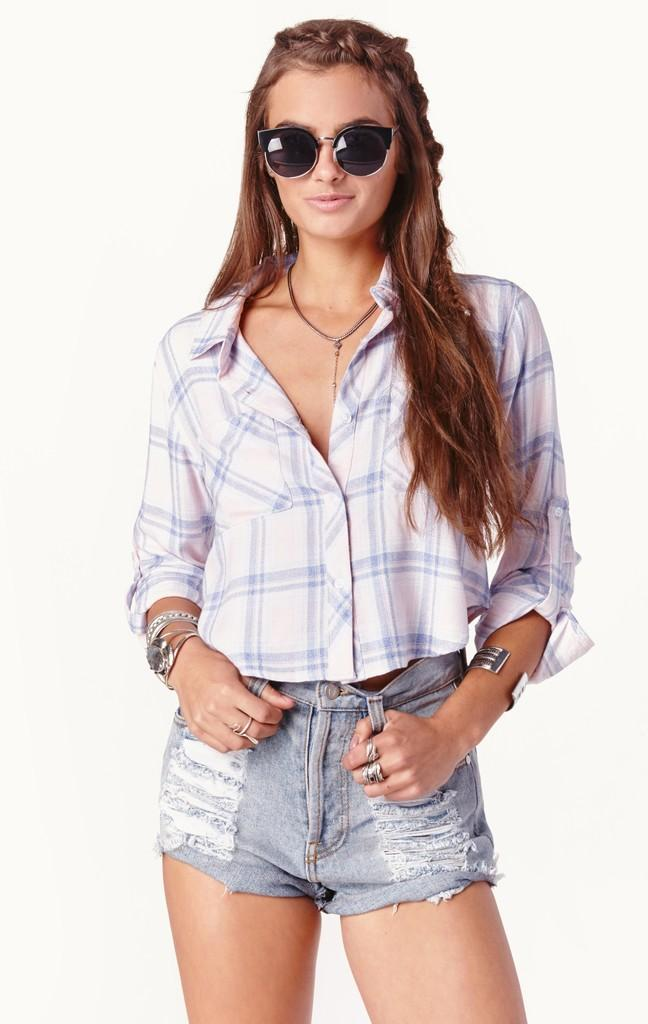Who is the main subject in the image? There is a woman in the image. What is the woman doing in the image? The woman is standing. What accessory is the woman wearing in the image? The woman is wearing spectacles. What is the color of the background in the image? The background of the image is white. What type of bone is visible in the image? There is no bone present in the image. What disease is the woman suffering from in the image? There is no indication of any disease in the image. 